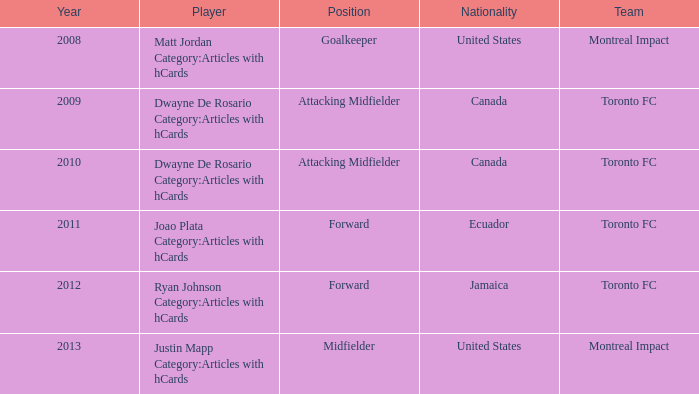After 2009, who was the player that has a nationality of Canada? Dwayne De Rosario Category:Articles with hCards. 